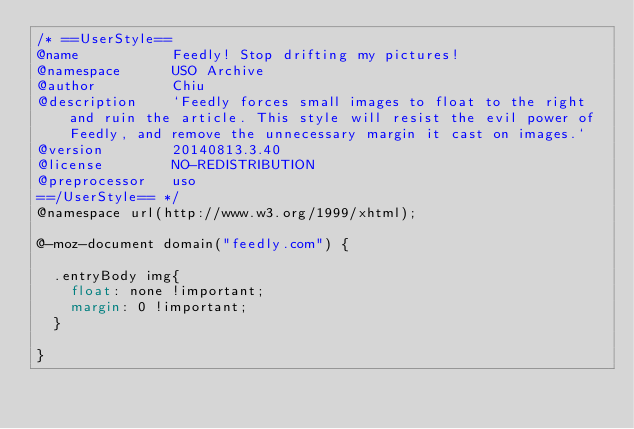<code> <loc_0><loc_0><loc_500><loc_500><_CSS_>/* ==UserStyle==
@name           Feedly! Stop drifting my pictures!
@namespace      USO Archive
@author         Chiu
@description    `Feedly forces small images to float to the right and ruin the article. This style will resist the evil power of Feedly, and remove the unnecessary margin it cast on images.`
@version        20140813.3.40
@license        NO-REDISTRIBUTION
@preprocessor   uso
==/UserStyle== */
@namespace url(http://www.w3.org/1999/xhtml);

@-moz-document domain("feedly.com") {
  
  .entryBody img{
    float: none !important;
    margin: 0 !important;
  }
  
}</code> 